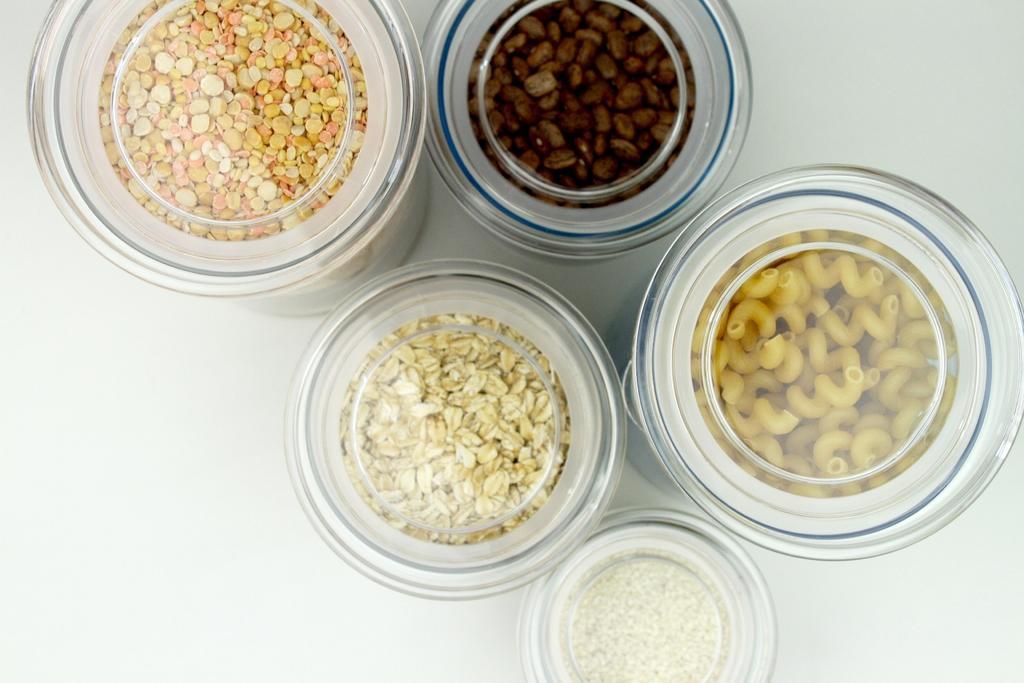Can you describe this image briefly? In this picture I can observe grains, coffee beans and other food items placed in the small containers. These are placed on the white color surface. 